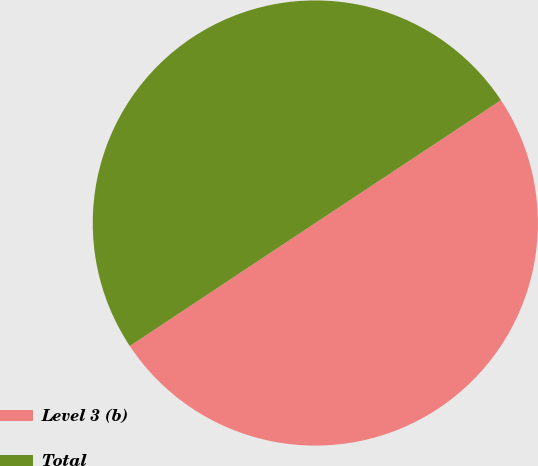<chart> <loc_0><loc_0><loc_500><loc_500><pie_chart><fcel>Level 3 (b)<fcel>Total<nl><fcel>49.98%<fcel>50.02%<nl></chart> 